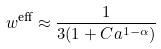Convert formula to latex. <formula><loc_0><loc_0><loc_500><loc_500>w ^ { \text {eff} } \approx \frac { 1 } { 3 ( 1 + C a ^ { 1 - \alpha } ) }</formula> 